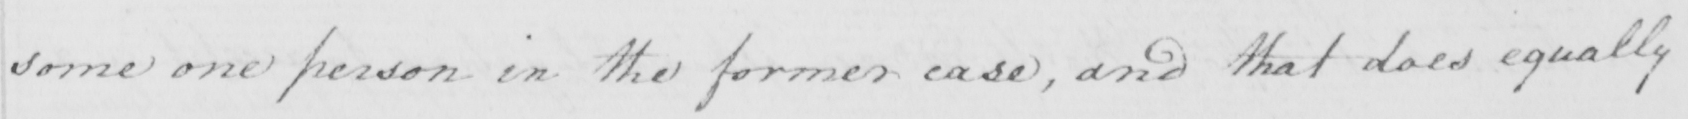Can you read and transcribe this handwriting? some one person in the former case , and that does equally 